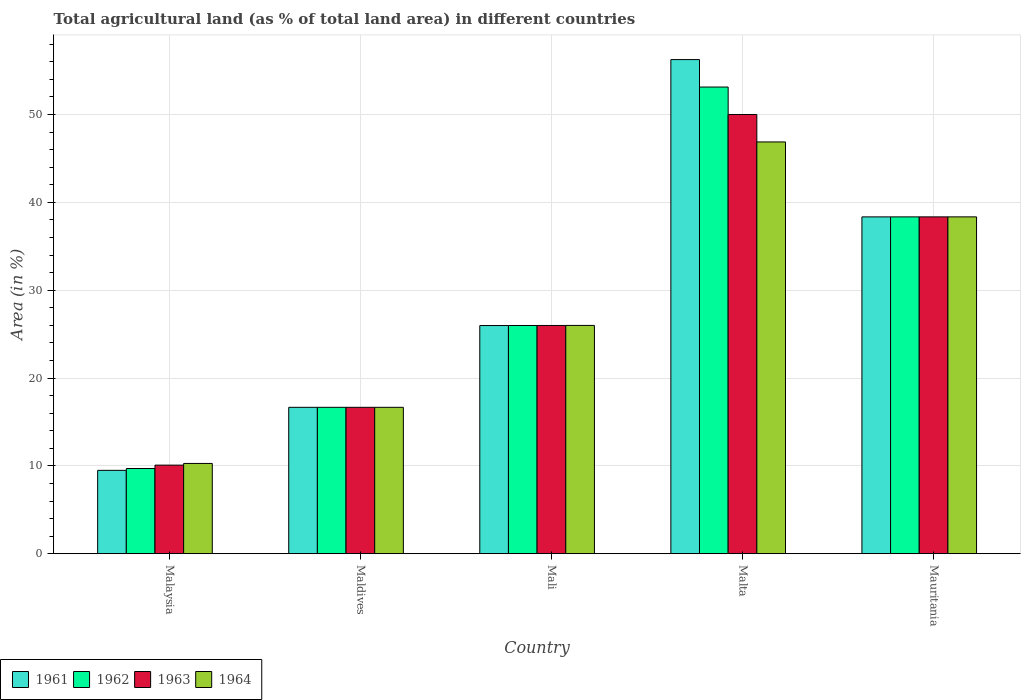How many different coloured bars are there?
Ensure brevity in your answer.  4. How many bars are there on the 2nd tick from the left?
Offer a terse response. 4. How many bars are there on the 1st tick from the right?
Offer a very short reply. 4. What is the label of the 1st group of bars from the left?
Provide a short and direct response. Malaysia. What is the percentage of agricultural land in 1962 in Malta?
Your response must be concise. 53.12. Across all countries, what is the maximum percentage of agricultural land in 1961?
Provide a succinct answer. 56.25. Across all countries, what is the minimum percentage of agricultural land in 1964?
Keep it short and to the point. 10.28. In which country was the percentage of agricultural land in 1962 maximum?
Provide a short and direct response. Malta. In which country was the percentage of agricultural land in 1962 minimum?
Provide a short and direct response. Malaysia. What is the total percentage of agricultural land in 1962 in the graph?
Make the answer very short. 143.82. What is the difference between the percentage of agricultural land in 1961 in Mali and that in Malta?
Offer a terse response. -30.27. What is the difference between the percentage of agricultural land in 1963 in Malta and the percentage of agricultural land in 1962 in Mauritania?
Offer a terse response. 11.66. What is the average percentage of agricultural land in 1961 per country?
Provide a succinct answer. 29.35. What is the difference between the percentage of agricultural land of/in 1961 and percentage of agricultural land of/in 1964 in Mauritania?
Offer a very short reply. -0. In how many countries, is the percentage of agricultural land in 1961 greater than 24 %?
Offer a terse response. 3. What is the ratio of the percentage of agricultural land in 1961 in Mali to that in Mauritania?
Your response must be concise. 0.68. Is the difference between the percentage of agricultural land in 1961 in Maldives and Malta greater than the difference between the percentage of agricultural land in 1964 in Maldives and Malta?
Provide a succinct answer. No. What is the difference between the highest and the second highest percentage of agricultural land in 1963?
Ensure brevity in your answer.  -24.01. What is the difference between the highest and the lowest percentage of agricultural land in 1963?
Ensure brevity in your answer.  39.91. Is it the case that in every country, the sum of the percentage of agricultural land in 1963 and percentage of agricultural land in 1961 is greater than the sum of percentage of agricultural land in 1964 and percentage of agricultural land in 1962?
Ensure brevity in your answer.  No. What does the 3rd bar from the left in Malta represents?
Your response must be concise. 1963. What does the 1st bar from the right in Mali represents?
Offer a terse response. 1964. Is it the case that in every country, the sum of the percentage of agricultural land in 1961 and percentage of agricultural land in 1962 is greater than the percentage of agricultural land in 1964?
Keep it short and to the point. Yes. How many bars are there?
Offer a very short reply. 20. Are all the bars in the graph horizontal?
Provide a succinct answer. No. Are the values on the major ticks of Y-axis written in scientific E-notation?
Give a very brief answer. No. Does the graph contain any zero values?
Ensure brevity in your answer.  No. Does the graph contain grids?
Ensure brevity in your answer.  Yes. How are the legend labels stacked?
Offer a very short reply. Horizontal. What is the title of the graph?
Provide a short and direct response. Total agricultural land (as % of total land area) in different countries. What is the label or title of the X-axis?
Your answer should be compact. Country. What is the label or title of the Y-axis?
Keep it short and to the point. Area (in %). What is the Area (in %) of 1961 in Malaysia?
Offer a very short reply. 9.49. What is the Area (in %) of 1962 in Malaysia?
Your answer should be compact. 9.7. What is the Area (in %) in 1963 in Malaysia?
Make the answer very short. 10.09. What is the Area (in %) of 1964 in Malaysia?
Provide a succinct answer. 10.28. What is the Area (in %) of 1961 in Maldives?
Your answer should be compact. 16.67. What is the Area (in %) in 1962 in Maldives?
Ensure brevity in your answer.  16.67. What is the Area (in %) of 1963 in Maldives?
Provide a short and direct response. 16.67. What is the Area (in %) in 1964 in Maldives?
Keep it short and to the point. 16.67. What is the Area (in %) in 1961 in Mali?
Offer a terse response. 25.98. What is the Area (in %) of 1962 in Mali?
Provide a short and direct response. 25.98. What is the Area (in %) in 1963 in Mali?
Offer a very short reply. 25.99. What is the Area (in %) in 1964 in Mali?
Provide a short and direct response. 25.99. What is the Area (in %) in 1961 in Malta?
Give a very brief answer. 56.25. What is the Area (in %) in 1962 in Malta?
Provide a short and direct response. 53.12. What is the Area (in %) in 1964 in Malta?
Your response must be concise. 46.88. What is the Area (in %) in 1961 in Mauritania?
Provide a succinct answer. 38.34. What is the Area (in %) of 1962 in Mauritania?
Your answer should be compact. 38.34. What is the Area (in %) of 1963 in Mauritania?
Keep it short and to the point. 38.35. What is the Area (in %) of 1964 in Mauritania?
Provide a short and direct response. 38.35. Across all countries, what is the maximum Area (in %) of 1961?
Give a very brief answer. 56.25. Across all countries, what is the maximum Area (in %) in 1962?
Offer a terse response. 53.12. Across all countries, what is the maximum Area (in %) in 1963?
Provide a short and direct response. 50. Across all countries, what is the maximum Area (in %) in 1964?
Offer a very short reply. 46.88. Across all countries, what is the minimum Area (in %) in 1961?
Make the answer very short. 9.49. Across all countries, what is the minimum Area (in %) in 1962?
Offer a terse response. 9.7. Across all countries, what is the minimum Area (in %) of 1963?
Ensure brevity in your answer.  10.09. Across all countries, what is the minimum Area (in %) in 1964?
Your answer should be very brief. 10.28. What is the total Area (in %) in 1961 in the graph?
Your response must be concise. 146.73. What is the total Area (in %) of 1962 in the graph?
Make the answer very short. 143.82. What is the total Area (in %) in 1963 in the graph?
Your response must be concise. 141.09. What is the total Area (in %) of 1964 in the graph?
Offer a terse response. 138.16. What is the difference between the Area (in %) in 1961 in Malaysia and that in Maldives?
Keep it short and to the point. -7.17. What is the difference between the Area (in %) in 1962 in Malaysia and that in Maldives?
Offer a terse response. -6.96. What is the difference between the Area (in %) in 1963 in Malaysia and that in Maldives?
Your response must be concise. -6.58. What is the difference between the Area (in %) of 1964 in Malaysia and that in Maldives?
Your answer should be compact. -6.39. What is the difference between the Area (in %) in 1961 in Malaysia and that in Mali?
Give a very brief answer. -16.49. What is the difference between the Area (in %) of 1962 in Malaysia and that in Mali?
Your answer should be very brief. -16.28. What is the difference between the Area (in %) in 1963 in Malaysia and that in Mali?
Ensure brevity in your answer.  -15.9. What is the difference between the Area (in %) of 1964 in Malaysia and that in Mali?
Give a very brief answer. -15.71. What is the difference between the Area (in %) in 1961 in Malaysia and that in Malta?
Keep it short and to the point. -46.76. What is the difference between the Area (in %) of 1962 in Malaysia and that in Malta?
Provide a short and direct response. -43.42. What is the difference between the Area (in %) of 1963 in Malaysia and that in Malta?
Make the answer very short. -39.91. What is the difference between the Area (in %) in 1964 in Malaysia and that in Malta?
Your response must be concise. -36.6. What is the difference between the Area (in %) of 1961 in Malaysia and that in Mauritania?
Ensure brevity in your answer.  -28.85. What is the difference between the Area (in %) in 1962 in Malaysia and that in Mauritania?
Provide a short and direct response. -28.64. What is the difference between the Area (in %) in 1963 in Malaysia and that in Mauritania?
Your answer should be compact. -28.26. What is the difference between the Area (in %) of 1964 in Malaysia and that in Mauritania?
Provide a short and direct response. -28.07. What is the difference between the Area (in %) of 1961 in Maldives and that in Mali?
Provide a short and direct response. -9.31. What is the difference between the Area (in %) of 1962 in Maldives and that in Mali?
Offer a very short reply. -9.32. What is the difference between the Area (in %) in 1963 in Maldives and that in Mali?
Give a very brief answer. -9.32. What is the difference between the Area (in %) of 1964 in Maldives and that in Mali?
Your response must be concise. -9.32. What is the difference between the Area (in %) of 1961 in Maldives and that in Malta?
Offer a terse response. -39.58. What is the difference between the Area (in %) in 1962 in Maldives and that in Malta?
Your answer should be very brief. -36.46. What is the difference between the Area (in %) in 1963 in Maldives and that in Malta?
Offer a very short reply. -33.33. What is the difference between the Area (in %) in 1964 in Maldives and that in Malta?
Ensure brevity in your answer.  -30.21. What is the difference between the Area (in %) in 1961 in Maldives and that in Mauritania?
Your answer should be very brief. -21.68. What is the difference between the Area (in %) of 1962 in Maldives and that in Mauritania?
Your response must be concise. -21.68. What is the difference between the Area (in %) of 1963 in Maldives and that in Mauritania?
Provide a short and direct response. -21.68. What is the difference between the Area (in %) of 1964 in Maldives and that in Mauritania?
Offer a terse response. -21.68. What is the difference between the Area (in %) of 1961 in Mali and that in Malta?
Offer a very short reply. -30.27. What is the difference between the Area (in %) in 1962 in Mali and that in Malta?
Offer a very short reply. -27.14. What is the difference between the Area (in %) of 1963 in Mali and that in Malta?
Your answer should be compact. -24.01. What is the difference between the Area (in %) in 1964 in Mali and that in Malta?
Provide a short and direct response. -20.88. What is the difference between the Area (in %) of 1961 in Mali and that in Mauritania?
Offer a terse response. -12.37. What is the difference between the Area (in %) of 1962 in Mali and that in Mauritania?
Make the answer very short. -12.36. What is the difference between the Area (in %) in 1963 in Mali and that in Mauritania?
Ensure brevity in your answer.  -12.36. What is the difference between the Area (in %) in 1964 in Mali and that in Mauritania?
Provide a succinct answer. -12.36. What is the difference between the Area (in %) in 1961 in Malta and that in Mauritania?
Offer a terse response. 17.91. What is the difference between the Area (in %) of 1962 in Malta and that in Mauritania?
Give a very brief answer. 14.78. What is the difference between the Area (in %) in 1963 in Malta and that in Mauritania?
Your response must be concise. 11.65. What is the difference between the Area (in %) in 1964 in Malta and that in Mauritania?
Your response must be concise. 8.53. What is the difference between the Area (in %) of 1961 in Malaysia and the Area (in %) of 1962 in Maldives?
Your answer should be compact. -7.17. What is the difference between the Area (in %) in 1961 in Malaysia and the Area (in %) in 1963 in Maldives?
Offer a terse response. -7.17. What is the difference between the Area (in %) of 1961 in Malaysia and the Area (in %) of 1964 in Maldives?
Keep it short and to the point. -7.17. What is the difference between the Area (in %) in 1962 in Malaysia and the Area (in %) in 1963 in Maldives?
Provide a short and direct response. -6.96. What is the difference between the Area (in %) of 1962 in Malaysia and the Area (in %) of 1964 in Maldives?
Offer a terse response. -6.96. What is the difference between the Area (in %) of 1963 in Malaysia and the Area (in %) of 1964 in Maldives?
Give a very brief answer. -6.58. What is the difference between the Area (in %) of 1961 in Malaysia and the Area (in %) of 1962 in Mali?
Offer a terse response. -16.49. What is the difference between the Area (in %) in 1961 in Malaysia and the Area (in %) in 1963 in Mali?
Offer a terse response. -16.49. What is the difference between the Area (in %) of 1961 in Malaysia and the Area (in %) of 1964 in Mali?
Ensure brevity in your answer.  -16.5. What is the difference between the Area (in %) in 1962 in Malaysia and the Area (in %) in 1963 in Mali?
Your answer should be compact. -16.28. What is the difference between the Area (in %) in 1962 in Malaysia and the Area (in %) in 1964 in Mali?
Your answer should be very brief. -16.29. What is the difference between the Area (in %) of 1963 in Malaysia and the Area (in %) of 1964 in Mali?
Offer a very short reply. -15.9. What is the difference between the Area (in %) in 1961 in Malaysia and the Area (in %) in 1962 in Malta?
Provide a short and direct response. -43.63. What is the difference between the Area (in %) of 1961 in Malaysia and the Area (in %) of 1963 in Malta?
Provide a succinct answer. -40.51. What is the difference between the Area (in %) of 1961 in Malaysia and the Area (in %) of 1964 in Malta?
Provide a short and direct response. -37.38. What is the difference between the Area (in %) of 1962 in Malaysia and the Area (in %) of 1963 in Malta?
Keep it short and to the point. -40.3. What is the difference between the Area (in %) of 1962 in Malaysia and the Area (in %) of 1964 in Malta?
Provide a short and direct response. -37.17. What is the difference between the Area (in %) in 1963 in Malaysia and the Area (in %) in 1964 in Malta?
Make the answer very short. -36.79. What is the difference between the Area (in %) in 1961 in Malaysia and the Area (in %) in 1962 in Mauritania?
Provide a short and direct response. -28.85. What is the difference between the Area (in %) in 1961 in Malaysia and the Area (in %) in 1963 in Mauritania?
Make the answer very short. -28.85. What is the difference between the Area (in %) of 1961 in Malaysia and the Area (in %) of 1964 in Mauritania?
Give a very brief answer. -28.85. What is the difference between the Area (in %) of 1962 in Malaysia and the Area (in %) of 1963 in Mauritania?
Your response must be concise. -28.64. What is the difference between the Area (in %) of 1962 in Malaysia and the Area (in %) of 1964 in Mauritania?
Give a very brief answer. -28.64. What is the difference between the Area (in %) of 1963 in Malaysia and the Area (in %) of 1964 in Mauritania?
Provide a short and direct response. -28.26. What is the difference between the Area (in %) in 1961 in Maldives and the Area (in %) in 1962 in Mali?
Your answer should be compact. -9.32. What is the difference between the Area (in %) of 1961 in Maldives and the Area (in %) of 1963 in Mali?
Provide a succinct answer. -9.32. What is the difference between the Area (in %) in 1961 in Maldives and the Area (in %) in 1964 in Mali?
Your answer should be very brief. -9.32. What is the difference between the Area (in %) in 1962 in Maldives and the Area (in %) in 1963 in Mali?
Offer a terse response. -9.32. What is the difference between the Area (in %) in 1962 in Maldives and the Area (in %) in 1964 in Mali?
Provide a succinct answer. -9.32. What is the difference between the Area (in %) of 1963 in Maldives and the Area (in %) of 1964 in Mali?
Provide a succinct answer. -9.32. What is the difference between the Area (in %) in 1961 in Maldives and the Area (in %) in 1962 in Malta?
Make the answer very short. -36.46. What is the difference between the Area (in %) in 1961 in Maldives and the Area (in %) in 1963 in Malta?
Make the answer very short. -33.33. What is the difference between the Area (in %) in 1961 in Maldives and the Area (in %) in 1964 in Malta?
Ensure brevity in your answer.  -30.21. What is the difference between the Area (in %) of 1962 in Maldives and the Area (in %) of 1963 in Malta?
Ensure brevity in your answer.  -33.33. What is the difference between the Area (in %) in 1962 in Maldives and the Area (in %) in 1964 in Malta?
Ensure brevity in your answer.  -30.21. What is the difference between the Area (in %) of 1963 in Maldives and the Area (in %) of 1964 in Malta?
Your answer should be very brief. -30.21. What is the difference between the Area (in %) in 1961 in Maldives and the Area (in %) in 1962 in Mauritania?
Your answer should be compact. -21.68. What is the difference between the Area (in %) in 1961 in Maldives and the Area (in %) in 1963 in Mauritania?
Provide a short and direct response. -21.68. What is the difference between the Area (in %) in 1961 in Maldives and the Area (in %) in 1964 in Mauritania?
Keep it short and to the point. -21.68. What is the difference between the Area (in %) of 1962 in Maldives and the Area (in %) of 1963 in Mauritania?
Your answer should be compact. -21.68. What is the difference between the Area (in %) in 1962 in Maldives and the Area (in %) in 1964 in Mauritania?
Offer a terse response. -21.68. What is the difference between the Area (in %) in 1963 in Maldives and the Area (in %) in 1964 in Mauritania?
Give a very brief answer. -21.68. What is the difference between the Area (in %) of 1961 in Mali and the Area (in %) of 1962 in Malta?
Provide a short and direct response. -27.15. What is the difference between the Area (in %) of 1961 in Mali and the Area (in %) of 1963 in Malta?
Your response must be concise. -24.02. What is the difference between the Area (in %) of 1961 in Mali and the Area (in %) of 1964 in Malta?
Provide a short and direct response. -20.9. What is the difference between the Area (in %) in 1962 in Mali and the Area (in %) in 1963 in Malta?
Offer a very short reply. -24.02. What is the difference between the Area (in %) in 1962 in Mali and the Area (in %) in 1964 in Malta?
Ensure brevity in your answer.  -20.89. What is the difference between the Area (in %) in 1963 in Mali and the Area (in %) in 1964 in Malta?
Offer a terse response. -20.89. What is the difference between the Area (in %) of 1961 in Mali and the Area (in %) of 1962 in Mauritania?
Your answer should be compact. -12.37. What is the difference between the Area (in %) in 1961 in Mali and the Area (in %) in 1963 in Mauritania?
Make the answer very short. -12.37. What is the difference between the Area (in %) of 1961 in Mali and the Area (in %) of 1964 in Mauritania?
Your response must be concise. -12.37. What is the difference between the Area (in %) of 1962 in Mali and the Area (in %) of 1963 in Mauritania?
Give a very brief answer. -12.36. What is the difference between the Area (in %) in 1962 in Mali and the Area (in %) in 1964 in Mauritania?
Provide a succinct answer. -12.36. What is the difference between the Area (in %) in 1963 in Mali and the Area (in %) in 1964 in Mauritania?
Offer a very short reply. -12.36. What is the difference between the Area (in %) in 1961 in Malta and the Area (in %) in 1962 in Mauritania?
Offer a very short reply. 17.91. What is the difference between the Area (in %) in 1961 in Malta and the Area (in %) in 1963 in Mauritania?
Your response must be concise. 17.9. What is the difference between the Area (in %) in 1961 in Malta and the Area (in %) in 1964 in Mauritania?
Give a very brief answer. 17.9. What is the difference between the Area (in %) of 1962 in Malta and the Area (in %) of 1963 in Mauritania?
Provide a short and direct response. 14.78. What is the difference between the Area (in %) of 1962 in Malta and the Area (in %) of 1964 in Mauritania?
Provide a short and direct response. 14.78. What is the difference between the Area (in %) in 1963 in Malta and the Area (in %) in 1964 in Mauritania?
Your answer should be very brief. 11.65. What is the average Area (in %) of 1961 per country?
Your response must be concise. 29.35. What is the average Area (in %) of 1962 per country?
Your answer should be compact. 28.76. What is the average Area (in %) of 1963 per country?
Make the answer very short. 28.22. What is the average Area (in %) of 1964 per country?
Keep it short and to the point. 27.63. What is the difference between the Area (in %) of 1961 and Area (in %) of 1962 in Malaysia?
Provide a short and direct response. -0.21. What is the difference between the Area (in %) in 1961 and Area (in %) in 1963 in Malaysia?
Offer a very short reply. -0.6. What is the difference between the Area (in %) in 1961 and Area (in %) in 1964 in Malaysia?
Offer a terse response. -0.79. What is the difference between the Area (in %) of 1962 and Area (in %) of 1963 in Malaysia?
Give a very brief answer. -0.38. What is the difference between the Area (in %) of 1962 and Area (in %) of 1964 in Malaysia?
Offer a very short reply. -0.58. What is the difference between the Area (in %) of 1963 and Area (in %) of 1964 in Malaysia?
Ensure brevity in your answer.  -0.19. What is the difference between the Area (in %) in 1961 and Area (in %) in 1963 in Maldives?
Give a very brief answer. 0. What is the difference between the Area (in %) in 1962 and Area (in %) in 1963 in Maldives?
Provide a succinct answer. 0. What is the difference between the Area (in %) of 1962 and Area (in %) of 1964 in Maldives?
Provide a succinct answer. 0. What is the difference between the Area (in %) in 1963 and Area (in %) in 1964 in Maldives?
Your answer should be compact. 0. What is the difference between the Area (in %) of 1961 and Area (in %) of 1962 in Mali?
Provide a short and direct response. -0. What is the difference between the Area (in %) in 1961 and Area (in %) in 1963 in Mali?
Your response must be concise. -0.01. What is the difference between the Area (in %) of 1961 and Area (in %) of 1964 in Mali?
Keep it short and to the point. -0.01. What is the difference between the Area (in %) of 1962 and Area (in %) of 1963 in Mali?
Your response must be concise. -0. What is the difference between the Area (in %) of 1962 and Area (in %) of 1964 in Mali?
Ensure brevity in your answer.  -0.01. What is the difference between the Area (in %) in 1963 and Area (in %) in 1964 in Mali?
Offer a terse response. -0. What is the difference between the Area (in %) of 1961 and Area (in %) of 1962 in Malta?
Provide a succinct answer. 3.12. What is the difference between the Area (in %) of 1961 and Area (in %) of 1963 in Malta?
Ensure brevity in your answer.  6.25. What is the difference between the Area (in %) of 1961 and Area (in %) of 1964 in Malta?
Make the answer very short. 9.38. What is the difference between the Area (in %) of 1962 and Area (in %) of 1963 in Malta?
Your response must be concise. 3.12. What is the difference between the Area (in %) in 1962 and Area (in %) in 1964 in Malta?
Make the answer very short. 6.25. What is the difference between the Area (in %) in 1963 and Area (in %) in 1964 in Malta?
Your answer should be compact. 3.12. What is the difference between the Area (in %) of 1961 and Area (in %) of 1963 in Mauritania?
Give a very brief answer. -0. What is the difference between the Area (in %) in 1961 and Area (in %) in 1964 in Mauritania?
Ensure brevity in your answer.  -0. What is the difference between the Area (in %) of 1962 and Area (in %) of 1963 in Mauritania?
Offer a terse response. -0. What is the difference between the Area (in %) in 1962 and Area (in %) in 1964 in Mauritania?
Your answer should be very brief. -0. What is the ratio of the Area (in %) of 1961 in Malaysia to that in Maldives?
Ensure brevity in your answer.  0.57. What is the ratio of the Area (in %) of 1962 in Malaysia to that in Maldives?
Provide a short and direct response. 0.58. What is the ratio of the Area (in %) of 1963 in Malaysia to that in Maldives?
Make the answer very short. 0.61. What is the ratio of the Area (in %) in 1964 in Malaysia to that in Maldives?
Keep it short and to the point. 0.62. What is the ratio of the Area (in %) of 1961 in Malaysia to that in Mali?
Provide a short and direct response. 0.37. What is the ratio of the Area (in %) of 1962 in Malaysia to that in Mali?
Your response must be concise. 0.37. What is the ratio of the Area (in %) in 1963 in Malaysia to that in Mali?
Offer a very short reply. 0.39. What is the ratio of the Area (in %) of 1964 in Malaysia to that in Mali?
Offer a very short reply. 0.4. What is the ratio of the Area (in %) of 1961 in Malaysia to that in Malta?
Your response must be concise. 0.17. What is the ratio of the Area (in %) in 1962 in Malaysia to that in Malta?
Provide a short and direct response. 0.18. What is the ratio of the Area (in %) in 1963 in Malaysia to that in Malta?
Ensure brevity in your answer.  0.2. What is the ratio of the Area (in %) in 1964 in Malaysia to that in Malta?
Your answer should be compact. 0.22. What is the ratio of the Area (in %) in 1961 in Malaysia to that in Mauritania?
Make the answer very short. 0.25. What is the ratio of the Area (in %) in 1962 in Malaysia to that in Mauritania?
Your response must be concise. 0.25. What is the ratio of the Area (in %) of 1963 in Malaysia to that in Mauritania?
Offer a terse response. 0.26. What is the ratio of the Area (in %) of 1964 in Malaysia to that in Mauritania?
Provide a succinct answer. 0.27. What is the ratio of the Area (in %) of 1961 in Maldives to that in Mali?
Offer a very short reply. 0.64. What is the ratio of the Area (in %) of 1962 in Maldives to that in Mali?
Offer a terse response. 0.64. What is the ratio of the Area (in %) of 1963 in Maldives to that in Mali?
Offer a very short reply. 0.64. What is the ratio of the Area (in %) of 1964 in Maldives to that in Mali?
Ensure brevity in your answer.  0.64. What is the ratio of the Area (in %) of 1961 in Maldives to that in Malta?
Offer a terse response. 0.3. What is the ratio of the Area (in %) in 1962 in Maldives to that in Malta?
Keep it short and to the point. 0.31. What is the ratio of the Area (in %) of 1964 in Maldives to that in Malta?
Make the answer very short. 0.36. What is the ratio of the Area (in %) of 1961 in Maldives to that in Mauritania?
Make the answer very short. 0.43. What is the ratio of the Area (in %) of 1962 in Maldives to that in Mauritania?
Provide a succinct answer. 0.43. What is the ratio of the Area (in %) of 1963 in Maldives to that in Mauritania?
Give a very brief answer. 0.43. What is the ratio of the Area (in %) in 1964 in Maldives to that in Mauritania?
Keep it short and to the point. 0.43. What is the ratio of the Area (in %) of 1961 in Mali to that in Malta?
Give a very brief answer. 0.46. What is the ratio of the Area (in %) of 1962 in Mali to that in Malta?
Provide a succinct answer. 0.49. What is the ratio of the Area (in %) of 1963 in Mali to that in Malta?
Make the answer very short. 0.52. What is the ratio of the Area (in %) of 1964 in Mali to that in Malta?
Ensure brevity in your answer.  0.55. What is the ratio of the Area (in %) in 1961 in Mali to that in Mauritania?
Your response must be concise. 0.68. What is the ratio of the Area (in %) of 1962 in Mali to that in Mauritania?
Ensure brevity in your answer.  0.68. What is the ratio of the Area (in %) of 1963 in Mali to that in Mauritania?
Offer a terse response. 0.68. What is the ratio of the Area (in %) of 1964 in Mali to that in Mauritania?
Provide a short and direct response. 0.68. What is the ratio of the Area (in %) of 1961 in Malta to that in Mauritania?
Keep it short and to the point. 1.47. What is the ratio of the Area (in %) of 1962 in Malta to that in Mauritania?
Provide a succinct answer. 1.39. What is the ratio of the Area (in %) of 1963 in Malta to that in Mauritania?
Ensure brevity in your answer.  1.3. What is the ratio of the Area (in %) of 1964 in Malta to that in Mauritania?
Your response must be concise. 1.22. What is the difference between the highest and the second highest Area (in %) of 1961?
Your response must be concise. 17.91. What is the difference between the highest and the second highest Area (in %) in 1962?
Your response must be concise. 14.78. What is the difference between the highest and the second highest Area (in %) of 1963?
Offer a very short reply. 11.65. What is the difference between the highest and the second highest Area (in %) of 1964?
Make the answer very short. 8.53. What is the difference between the highest and the lowest Area (in %) in 1961?
Your answer should be compact. 46.76. What is the difference between the highest and the lowest Area (in %) in 1962?
Make the answer very short. 43.42. What is the difference between the highest and the lowest Area (in %) of 1963?
Offer a very short reply. 39.91. What is the difference between the highest and the lowest Area (in %) of 1964?
Your response must be concise. 36.6. 